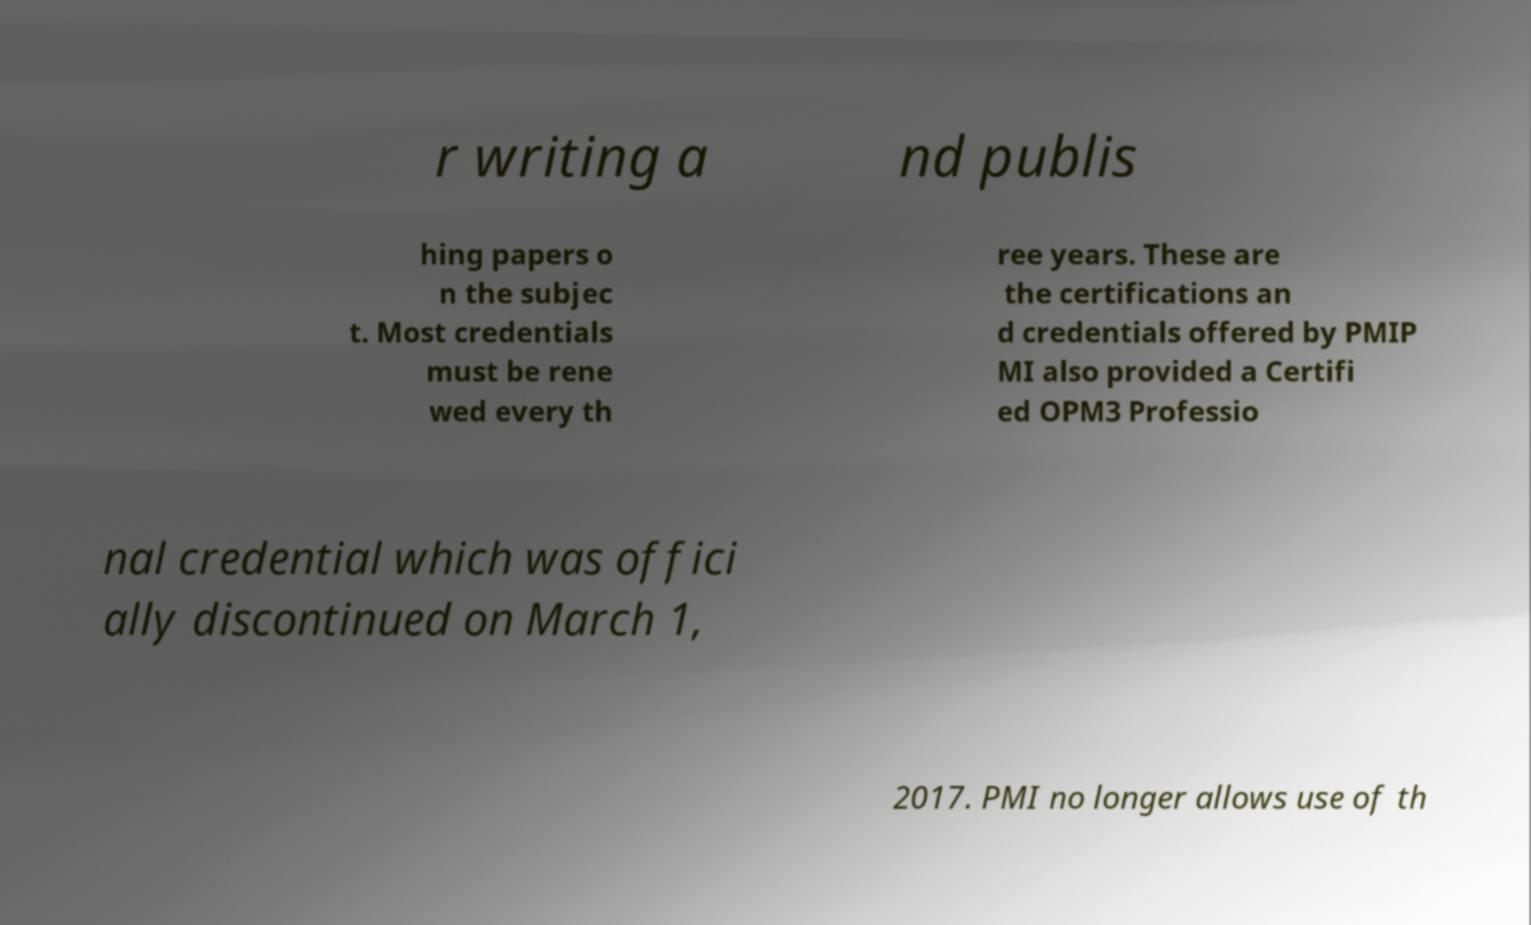Could you assist in decoding the text presented in this image and type it out clearly? r writing a nd publis hing papers o n the subjec t. Most credentials must be rene wed every th ree years. These are the certifications an d credentials offered by PMIP MI also provided a Certifi ed OPM3 Professio nal credential which was offici ally discontinued on March 1, 2017. PMI no longer allows use of th 